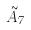<formula> <loc_0><loc_0><loc_500><loc_500>\tilde { A } _ { 7 }</formula> 